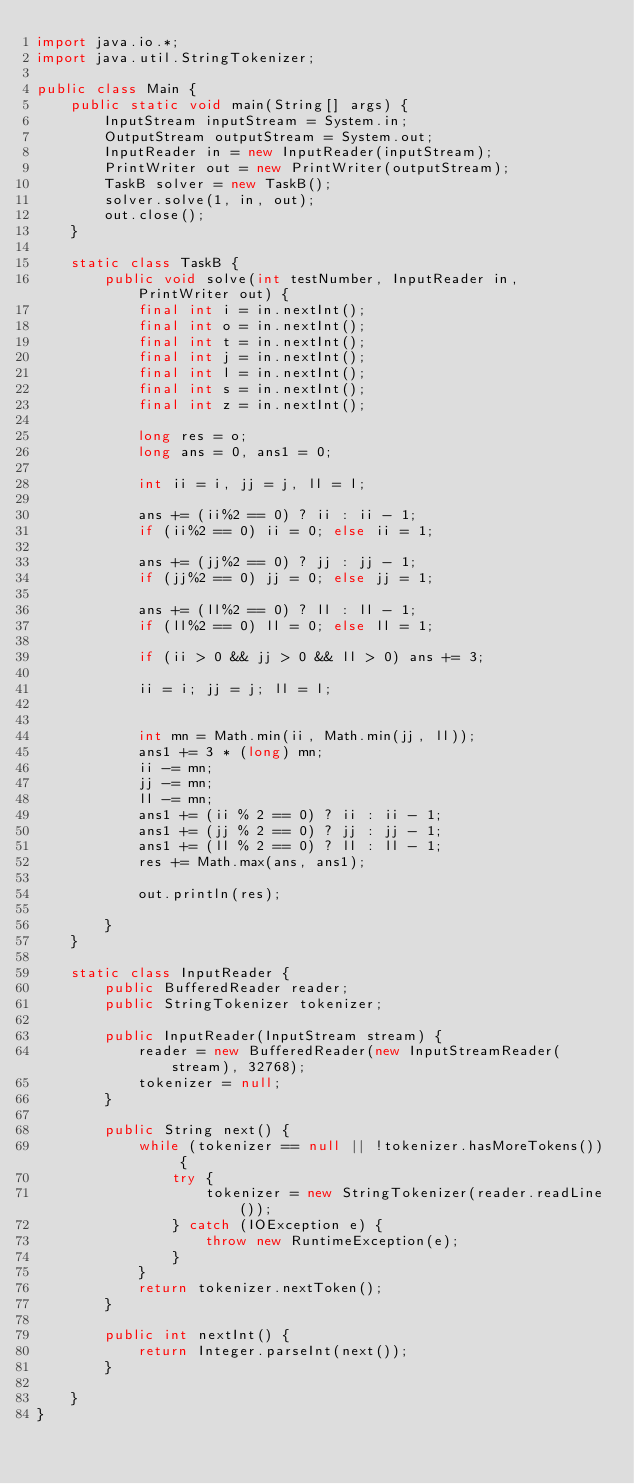Convert code to text. <code><loc_0><loc_0><loc_500><loc_500><_Java_>import java.io.*;
import java.util.StringTokenizer;

public class Main {
    public static void main(String[] args) {
        InputStream inputStream = System.in;
        OutputStream outputStream = System.out;
        InputReader in = new InputReader(inputStream);
        PrintWriter out = new PrintWriter(outputStream);
        TaskB solver = new TaskB();
        solver.solve(1, in, out);
        out.close();
    }

    static class TaskB {
        public void solve(int testNumber, InputReader in, PrintWriter out) {
            final int i = in.nextInt();
            final int o = in.nextInt();
            final int t = in.nextInt();
            final int j = in.nextInt();
            final int l = in.nextInt();
            final int s = in.nextInt();
            final int z = in.nextInt();

            long res = o;
            long ans = 0, ans1 = 0;

            int ii = i, jj = j, ll = l;

            ans += (ii%2 == 0) ? ii : ii - 1;
            if (ii%2 == 0) ii = 0; else ii = 1;

            ans += (jj%2 == 0) ? jj : jj - 1;
            if (jj%2 == 0) jj = 0; else jj = 1;

            ans += (ll%2 == 0) ? ll : ll - 1;
            if (ll%2 == 0) ll = 0; else ll = 1;

            if (ii > 0 && jj > 0 && ll > 0) ans += 3;

            ii = i; jj = j; ll = l;


            int mn = Math.min(ii, Math.min(jj, ll));
            ans1 += 3 * (long) mn;
            ii -= mn;
            jj -= mn;
            ll -= mn;
            ans1 += (ii % 2 == 0) ? ii : ii - 1;
            ans1 += (jj % 2 == 0) ? jj : jj - 1;
            ans1 += (ll % 2 == 0) ? ll : ll - 1;
            res += Math.max(ans, ans1);

            out.println(res);

        }
    }

    static class InputReader {
        public BufferedReader reader;
        public StringTokenizer tokenizer;

        public InputReader(InputStream stream) {
            reader = new BufferedReader(new InputStreamReader(stream), 32768);
            tokenizer = null;
        }

        public String next() {
            while (tokenizer == null || !tokenizer.hasMoreTokens()) {
                try {
                    tokenizer = new StringTokenizer(reader.readLine());
                } catch (IOException e) {
                    throw new RuntimeException(e);
                }
            }
            return tokenizer.nextToken();
        }

        public int nextInt() {
            return Integer.parseInt(next());
        }

    }
}

</code> 